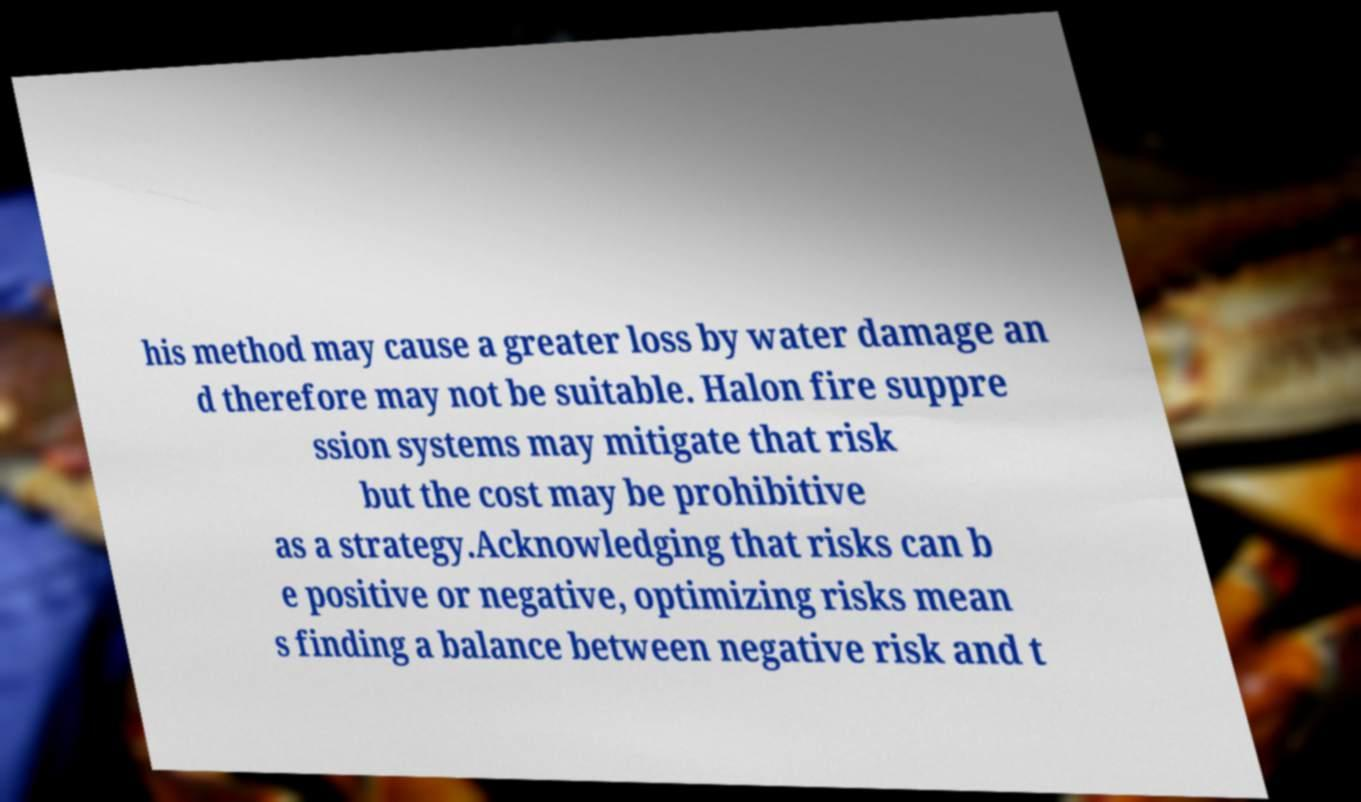Can you read and provide the text displayed in the image?This photo seems to have some interesting text. Can you extract and type it out for me? his method may cause a greater loss by water damage an d therefore may not be suitable. Halon fire suppre ssion systems may mitigate that risk but the cost may be prohibitive as a strategy.Acknowledging that risks can b e positive or negative, optimizing risks mean s finding a balance between negative risk and t 